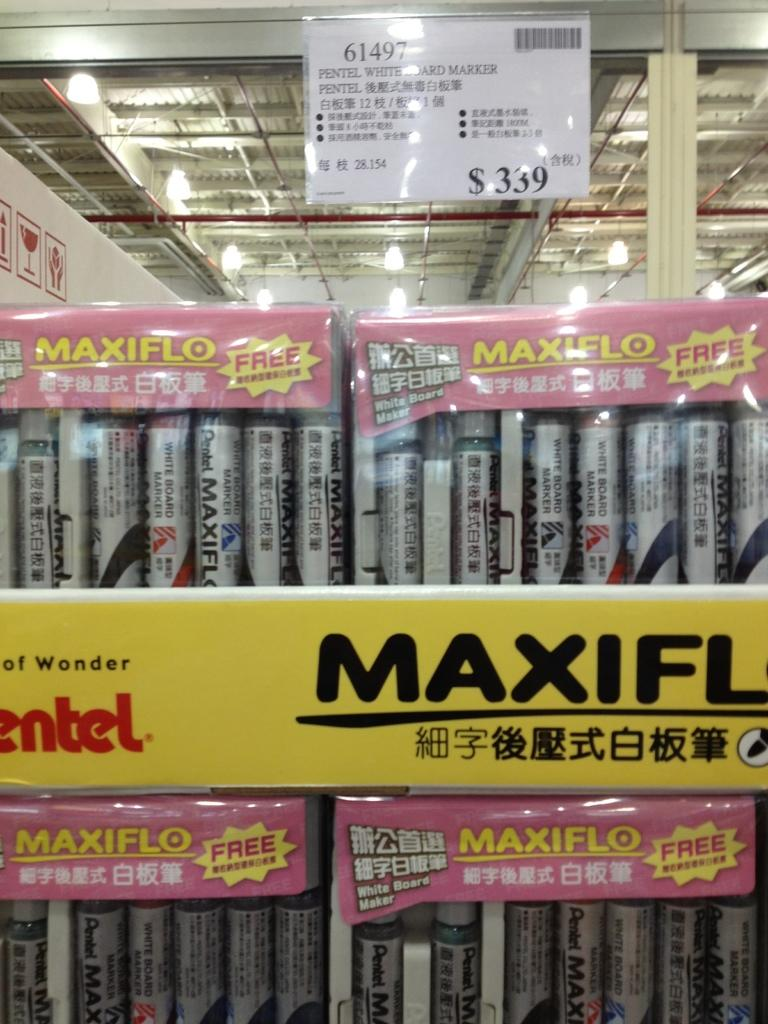<image>
Provide a brief description of the given image. A sign for a Pentel whiteboard marker says $339. 